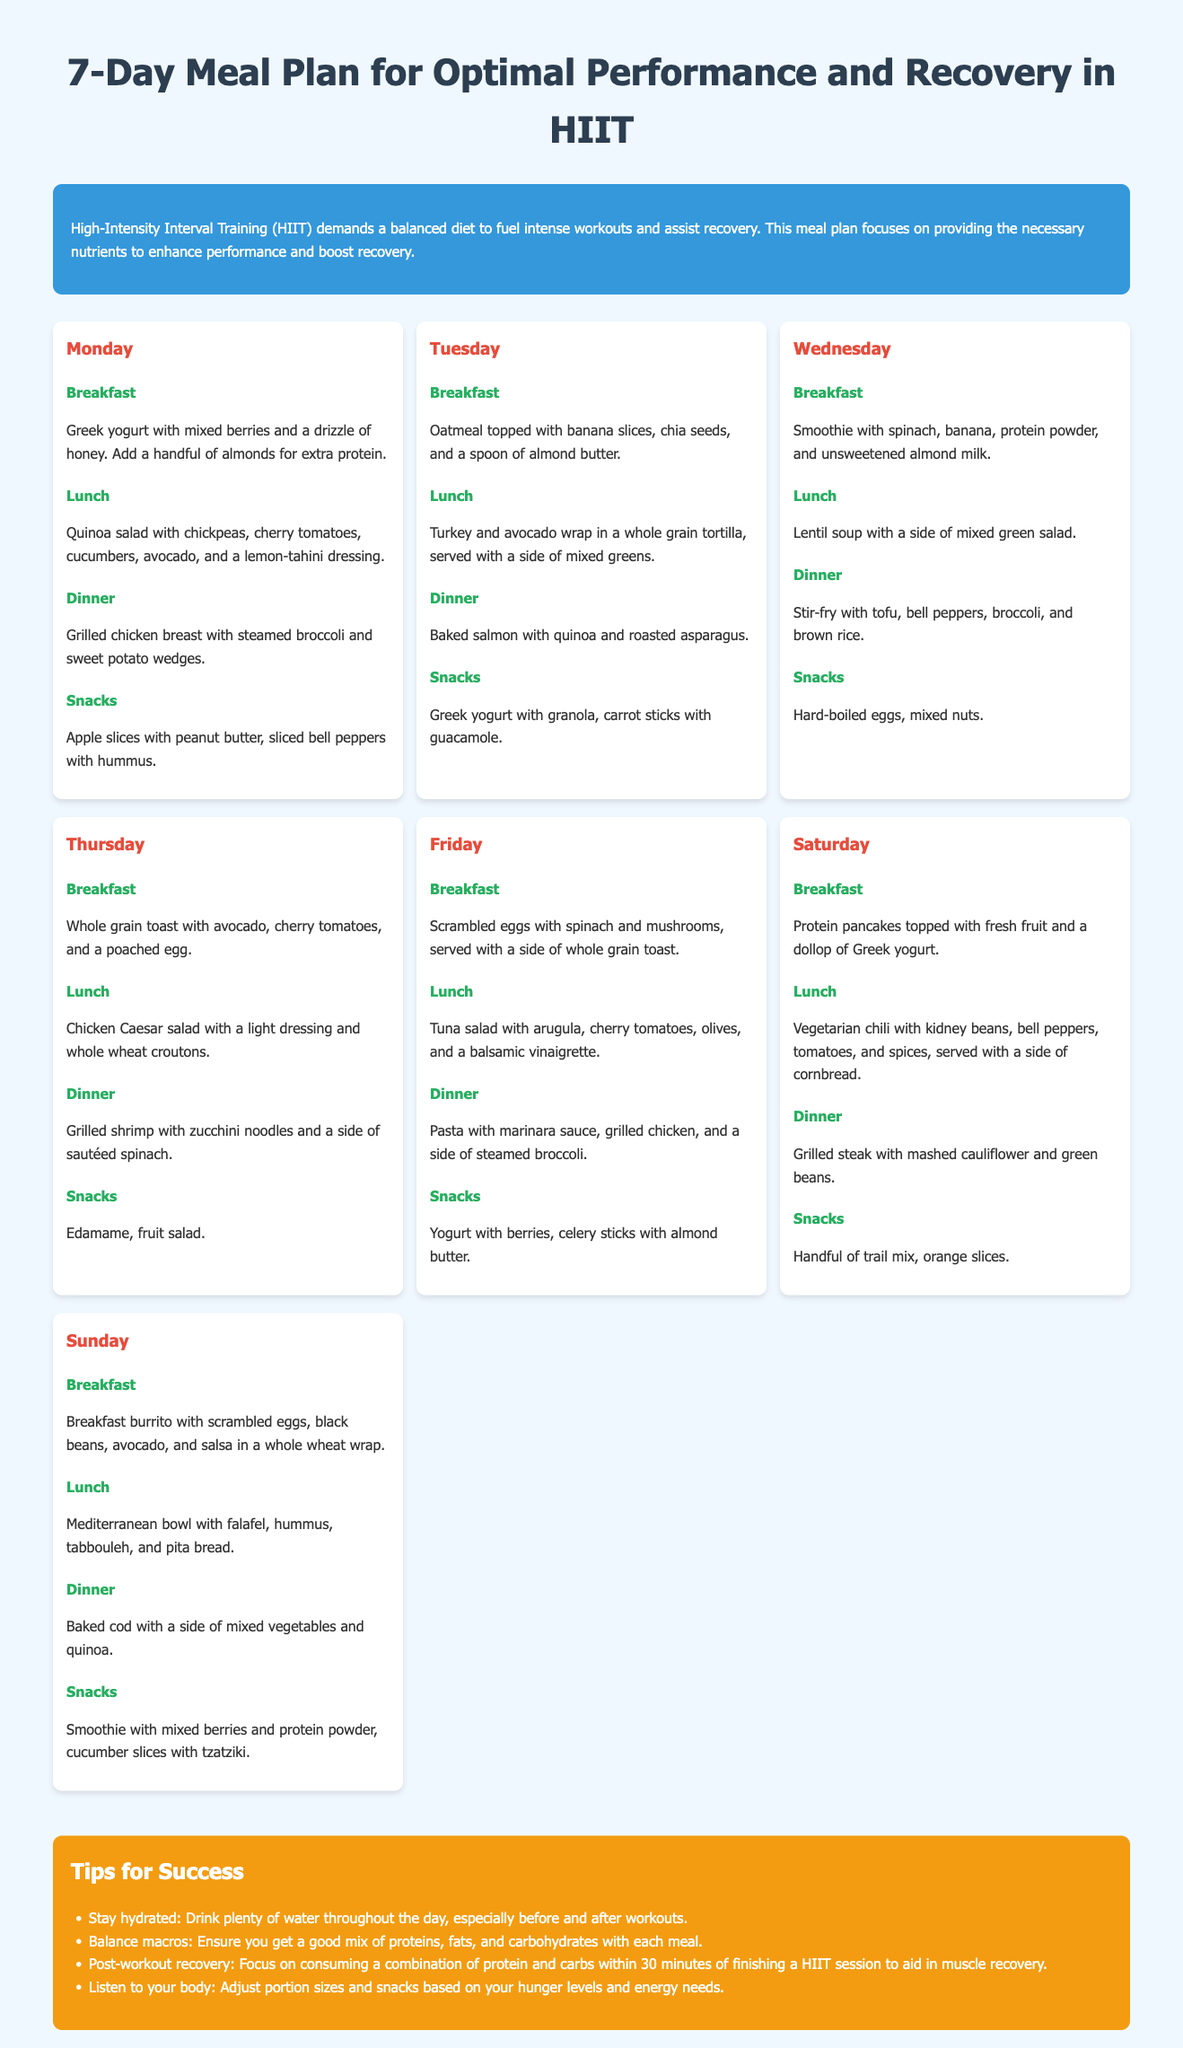What is the main focus of the meal plan? The meal plan focuses on providing the necessary nutrients to enhance performance and boost recovery.
Answer: Enhancing performance and boosting recovery How many days does the meal plan cover? The document outlines a meal plan for a full week, which is seven days.
Answer: Seven days What is served for breakfast on Wednesday? The breakfast for Wednesday includes a smoothie with spinach, banana, protein powder, and unsweetened almond milk.
Answer: Smoothie with spinach, banana, protein powder, and unsweetened almond milk Which snack is recommended on Monday? The snack options for Monday are apple slices with peanut butter and sliced bell peppers with hummus.
Answer: Apple slices with peanut butter, sliced bell peppers with hummus What type of diet does HIIT demand? HIIT demands a balanced diet to fuel intense workouts and assist recovery.
Answer: Balanced diet What is the key to post-workout recovery according to the tips? The tips suggest focusing on consuming a combination of protein and carbs within 30 minutes of finishing a HIIT session.
Answer: Combination of protein and carbs within 30 minutes How is the lunch on Saturday described? The lunch on Saturday is described as vegetarian chili with kidney beans, bell peppers, tomatoes, and spices, served with a side of cornbread.
Answer: Vegetarian chili with kidney beans, bell peppers, tomatoes, and spices, served with cornbread What consistency is maintained in the meal plan structure? The meal plan consistently includes breakfast, lunch, dinner, and snacks for each day.
Answer: Breakfast, lunch, dinner, and snacks for each day 